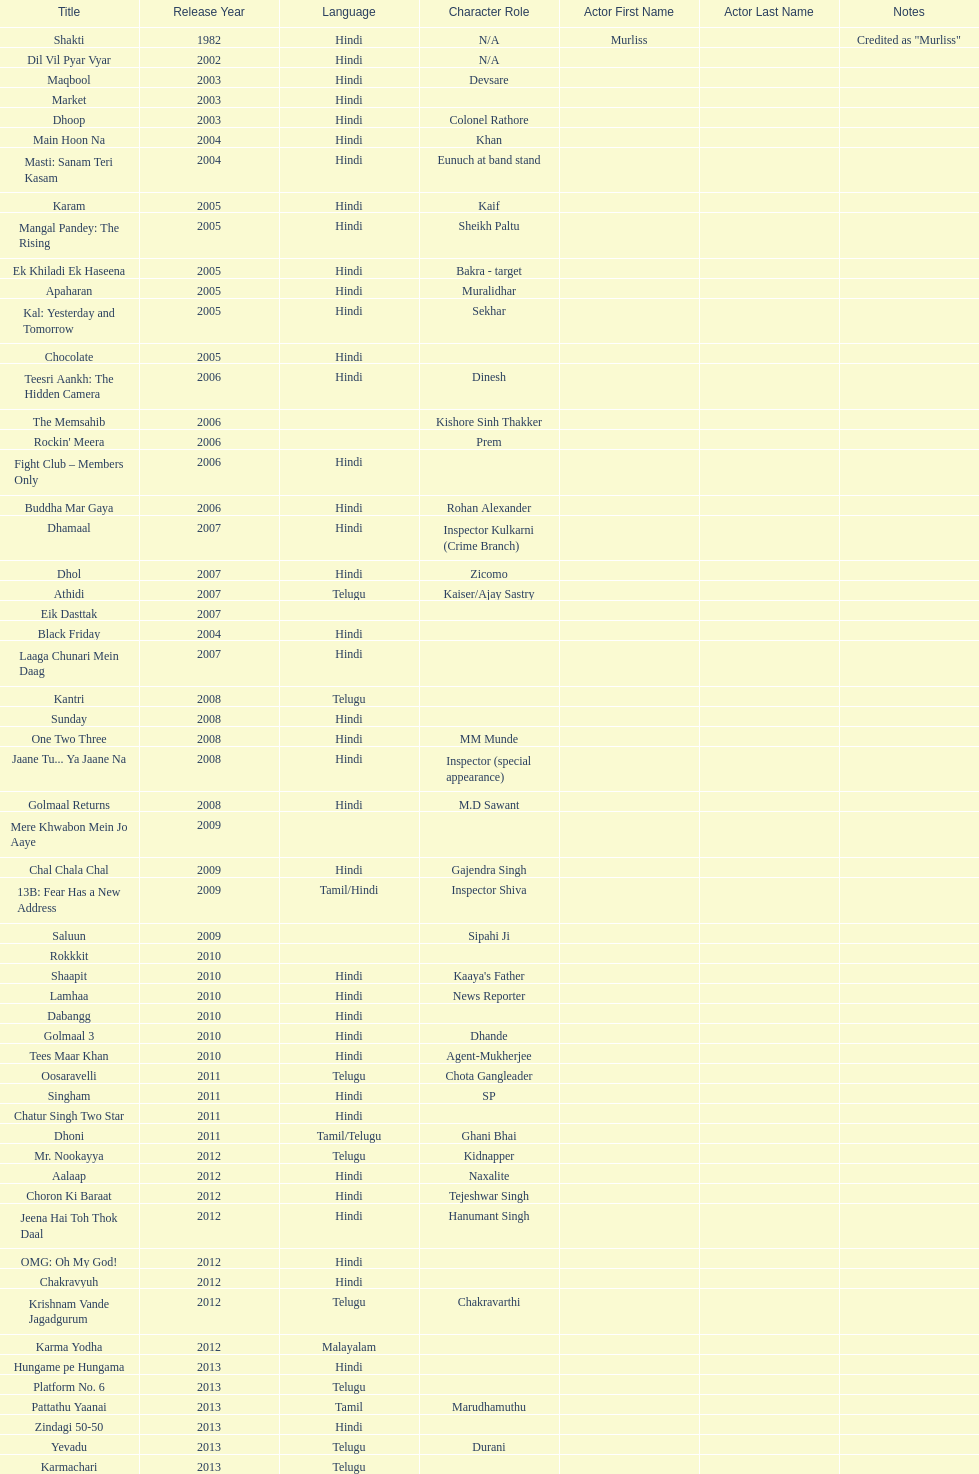What was the last malayalam film this actor starred in? Karma Yodha. 